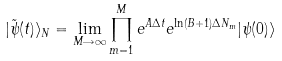Convert formula to latex. <formula><loc_0><loc_0><loc_500><loc_500>| \tilde { \psi } ( t ) \rangle _ { N } = \lim _ { M \rightarrow \infty } \prod _ { m = 1 } ^ { M } e ^ { A \Delta t } e ^ { \ln ( B + 1 ) \Delta N _ { m } } | \psi ( 0 ) \rangle</formula> 